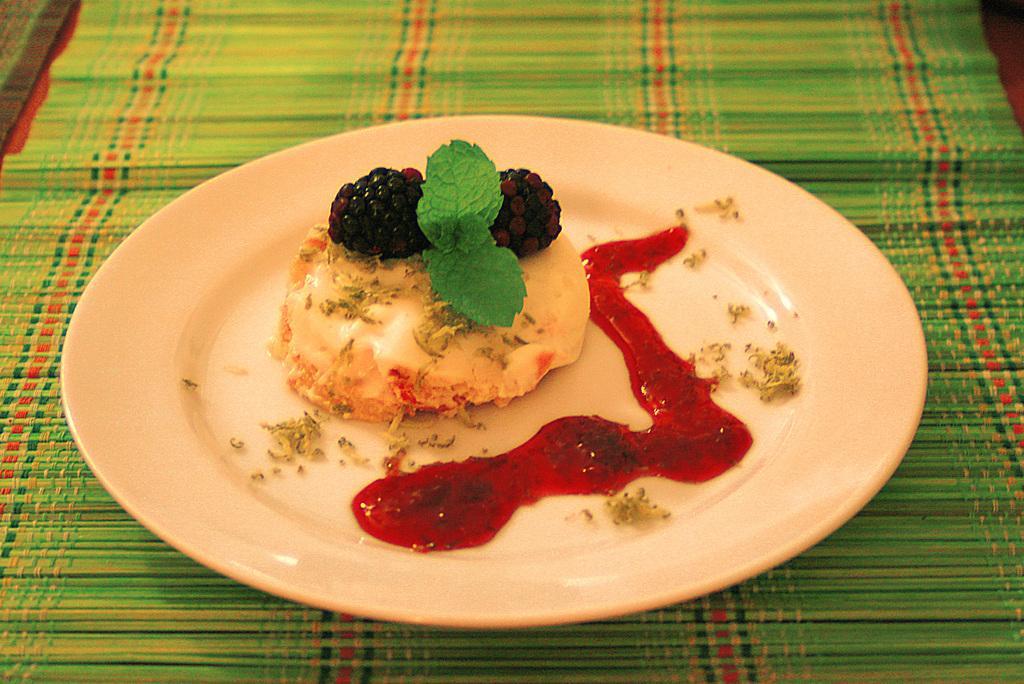Describe this image in one or two sentences. In the image there is some desert decorated with berries and served on a plate, beside the desert there is some sauce, the plate is kept on a mat. 